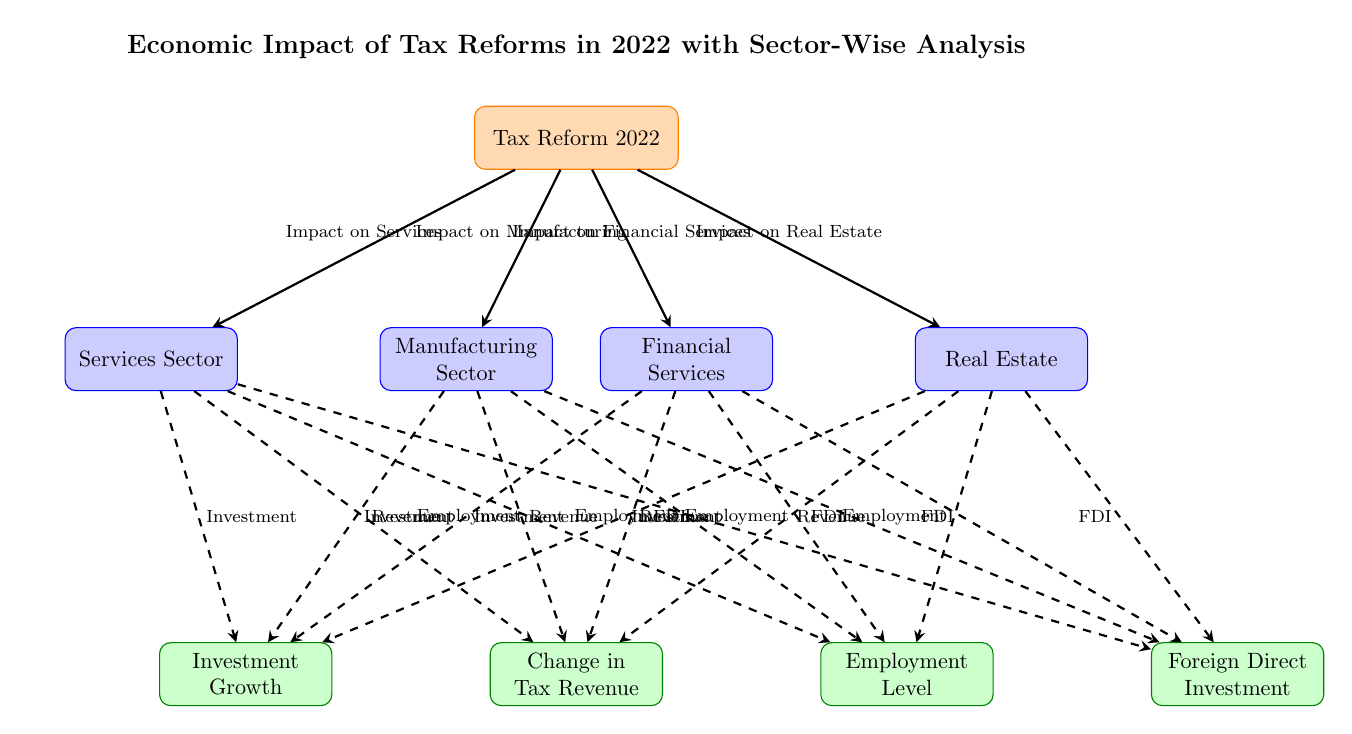What is the central theme of the diagram? The title of the diagram states that it represents the "Economic Impact of Tax Reforms in 2022 with Sector-Wise Analysis," indicating the central theme is the effects of tax reforms across various sectors.
Answer: Economic Impact of Tax Reforms in 2022 with Sector-Wise Analysis How many sectors are analyzed in the diagram? The diagram shows four sectors: Manufacturing, Services, Financial Services, and Real Estate, thus indicating that there are four sectors analyzed.
Answer: Four Which sector is located below the central node on the left? The node directly below and to the left of the central node is labeled 'Manufacturing Sector,' indicating that this is the sector located in that position.
Answer: Manufacturing Sector What is the relationship between the Financial Services sector and Change in Tax Revenue? A dashed arrow points from the Financial Services sector node to the Change in Tax Revenue node, indicating a relationship where changes in the Financial Services sector impact tax revenue.
Answer: There is a relationship represented by a dashed arrow Which impact category is directly to the right of Employment Level? The diagram positions Foreign Direct Investment directly to the right of Employment Level, indicating this is the next impact category in that direction.
Answer: Foreign Direct Investment How many arrows connect sectors to impact categories in total? Each of the four sectors connects to four different impact categories via dashed arrows. Therefore, there are 4 sectors multiplied by 4 impacts, totaling 16 arrows.
Answer: Sixteen Which sector is expected to influence investment growth most significantly? Each sector directly impacts investment growth according to the arrows; however, the specific impact or influence is not quantified in the diagram. The diagram does not specify one sector over another in its influence on investment growth.
Answer: The diagram does not specify What entities does the "Change in Tax Revenue" node connect to? The "Change in Tax Revenue" node is connected via dashed arrows to all four sectors, indicating that changes in tax revenue relate to each sector. Thus, it connects to Manufacturing, Services, Financial, and Real Estate sectors.
Answer: Manufacturing, Services, Financial, Real Estate Which impact category is placed exactly in the center below the central node? The "Change in Tax Revenue" is positioned directly below the central node, indicating its importance as an impact category in relation to the tax reform.
Answer: Change in Tax Revenue 